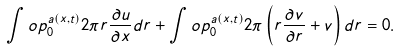Convert formula to latex. <formula><loc_0><loc_0><loc_500><loc_500>\int o p _ { 0 } ^ { a \left ( x , t \right ) } 2 \pi r \frac { \partial u } { \partial x } d r + \int o p _ { 0 } ^ { a \left ( x , t \right ) } 2 \pi \left ( r \frac { \partial v } { \partial r } + v \right ) d r = 0 .</formula> 